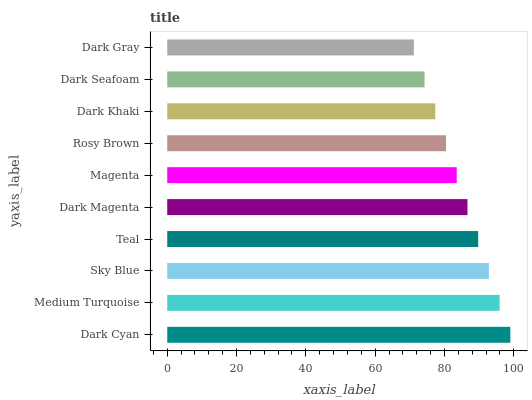Is Dark Gray the minimum?
Answer yes or no. Yes. Is Dark Cyan the maximum?
Answer yes or no. Yes. Is Medium Turquoise the minimum?
Answer yes or no. No. Is Medium Turquoise the maximum?
Answer yes or no. No. Is Dark Cyan greater than Medium Turquoise?
Answer yes or no. Yes. Is Medium Turquoise less than Dark Cyan?
Answer yes or no. Yes. Is Medium Turquoise greater than Dark Cyan?
Answer yes or no. No. Is Dark Cyan less than Medium Turquoise?
Answer yes or no. No. Is Dark Magenta the high median?
Answer yes or no. Yes. Is Magenta the low median?
Answer yes or no. Yes. Is Dark Cyan the high median?
Answer yes or no. No. Is Dark Gray the low median?
Answer yes or no. No. 